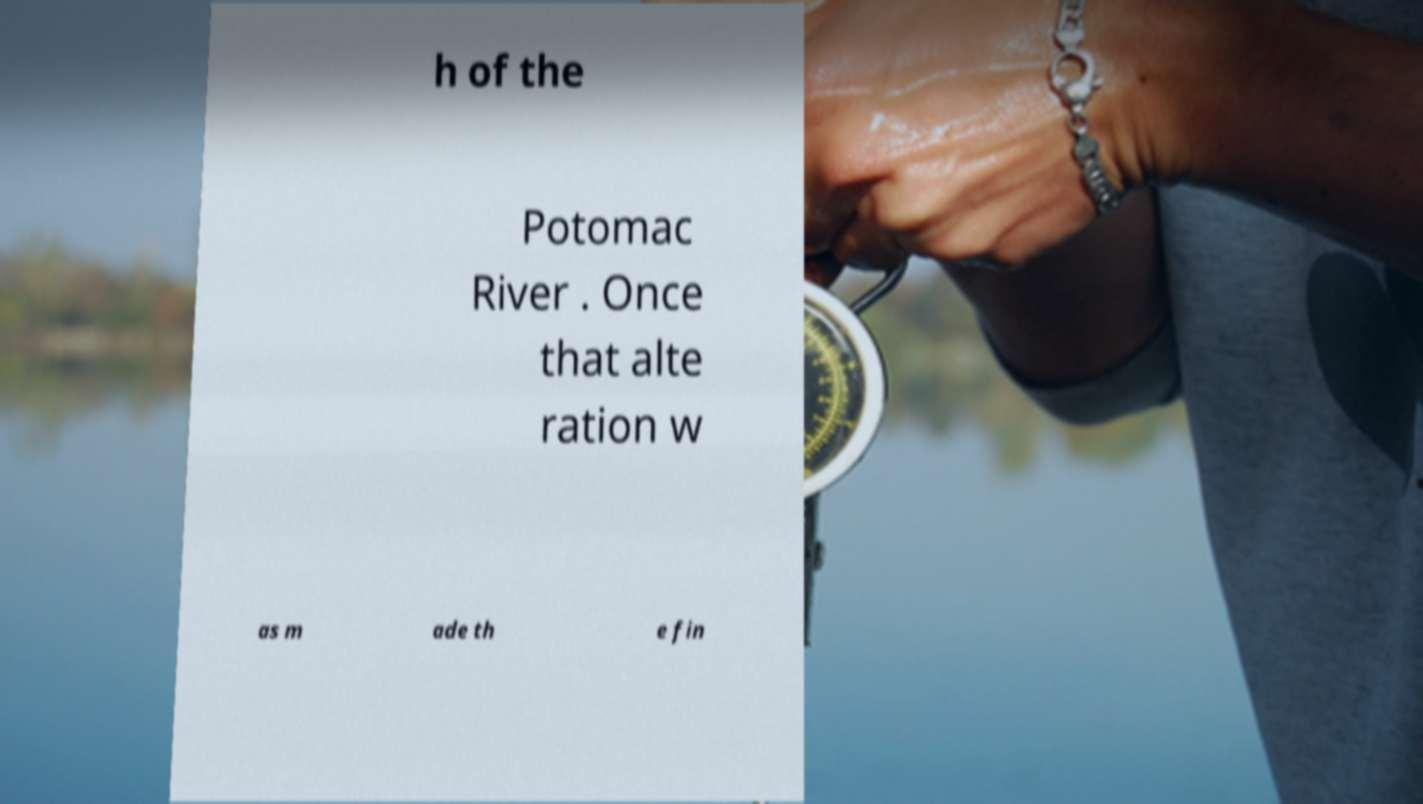For documentation purposes, I need the text within this image transcribed. Could you provide that? h of the Potomac River . Once that alte ration w as m ade th e fin 